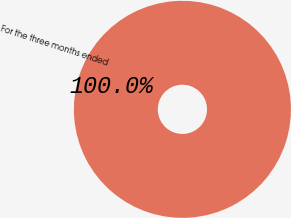<chart> <loc_0><loc_0><loc_500><loc_500><pie_chart><fcel>For the three months ended<nl><fcel>100.0%<nl></chart> 